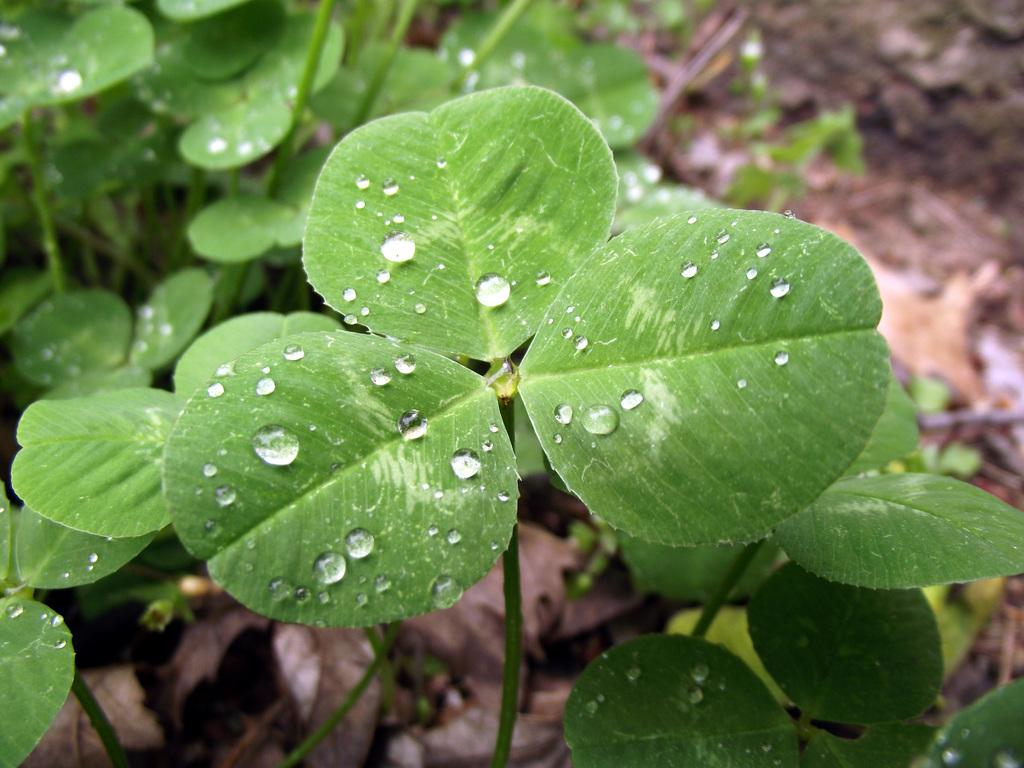What can be observed on the plant leaves in the image? There is dew on the plant leaves in the image. How would you describe the background of the image? The background of the image is blurred. What else can be seen on the ground in the background of the image? Dry leaves are visible on the ground in the background of the image. Can you tell me how many times the person in the image sneezes? There is no person present in the image, so it is not possible to determine how many times they sneeze. What type of milk is being poured into the bowl in the image? There is no milk or bowl present in the image; it features plant leaves with dew and a blurred background. 